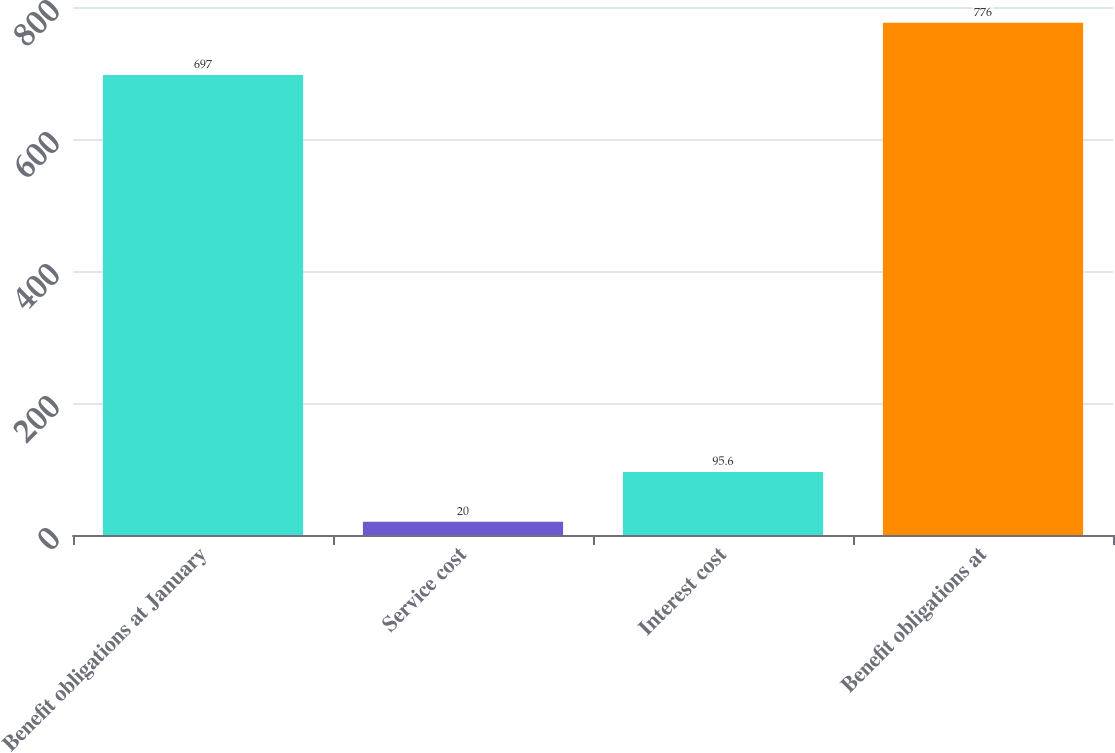Convert chart to OTSL. <chart><loc_0><loc_0><loc_500><loc_500><bar_chart><fcel>Benefit obligations at January<fcel>Service cost<fcel>Interest cost<fcel>Benefit obligations at<nl><fcel>697<fcel>20<fcel>95.6<fcel>776<nl></chart> 